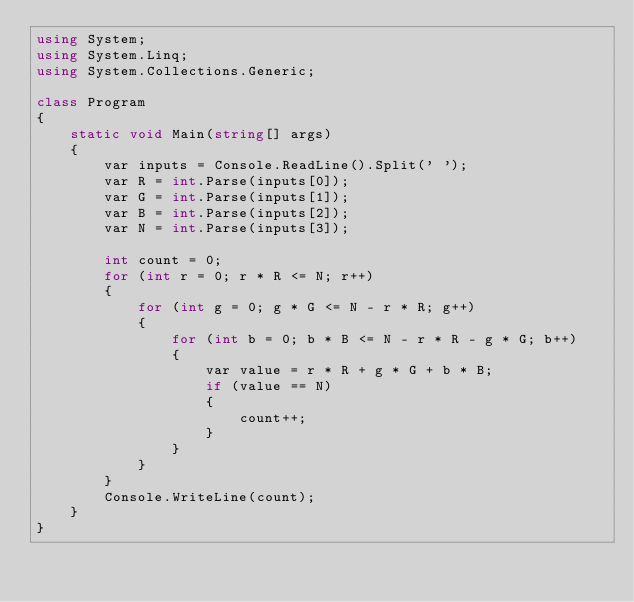<code> <loc_0><loc_0><loc_500><loc_500><_C#_>using System;
using System.Linq;
using System.Collections.Generic;

class Program
{
    static void Main(string[] args)
    {
        var inputs = Console.ReadLine().Split(' ');
        var R = int.Parse(inputs[0]);
        var G = int.Parse(inputs[1]);
        var B = int.Parse(inputs[2]);
        var N = int.Parse(inputs[3]);

        int count = 0;
        for (int r = 0; r * R <= N; r++)
        {
            for (int g = 0; g * G <= N - r * R; g++)
            {
                for (int b = 0; b * B <= N - r * R - g * G; b++)
                {
                    var value = r * R + g * G + b * B;
                    if (value == N)
                    {
                        count++;
                    }
                }
            }
        }
        Console.WriteLine(count);
    }
}

</code> 